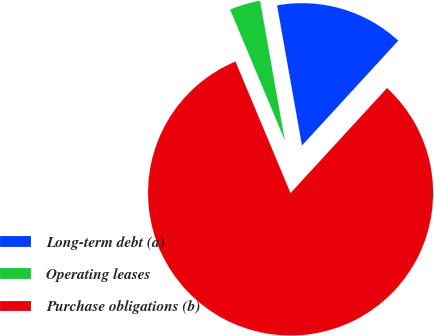Convert chart to OTSL. <chart><loc_0><loc_0><loc_500><loc_500><pie_chart><fcel>Long-term debt (a)<fcel>Operating leases<fcel>Purchase obligations (b)<nl><fcel>14.62%<fcel>3.51%<fcel>81.87%<nl></chart> 